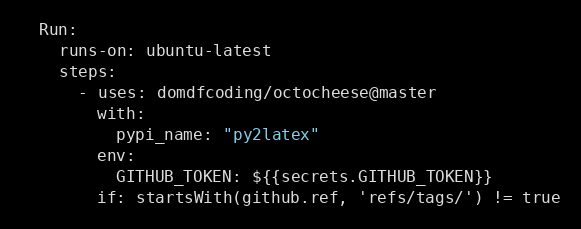<code> <loc_0><loc_0><loc_500><loc_500><_YAML_>  Run:
    runs-on: ubuntu-latest
    steps:
      - uses: domdfcoding/octocheese@master
        with:
          pypi_name: "py2latex"
        env:
          GITHUB_TOKEN: ${{secrets.GITHUB_TOKEN}}
        if: startsWith(github.ref, 'refs/tags/') != true
</code> 